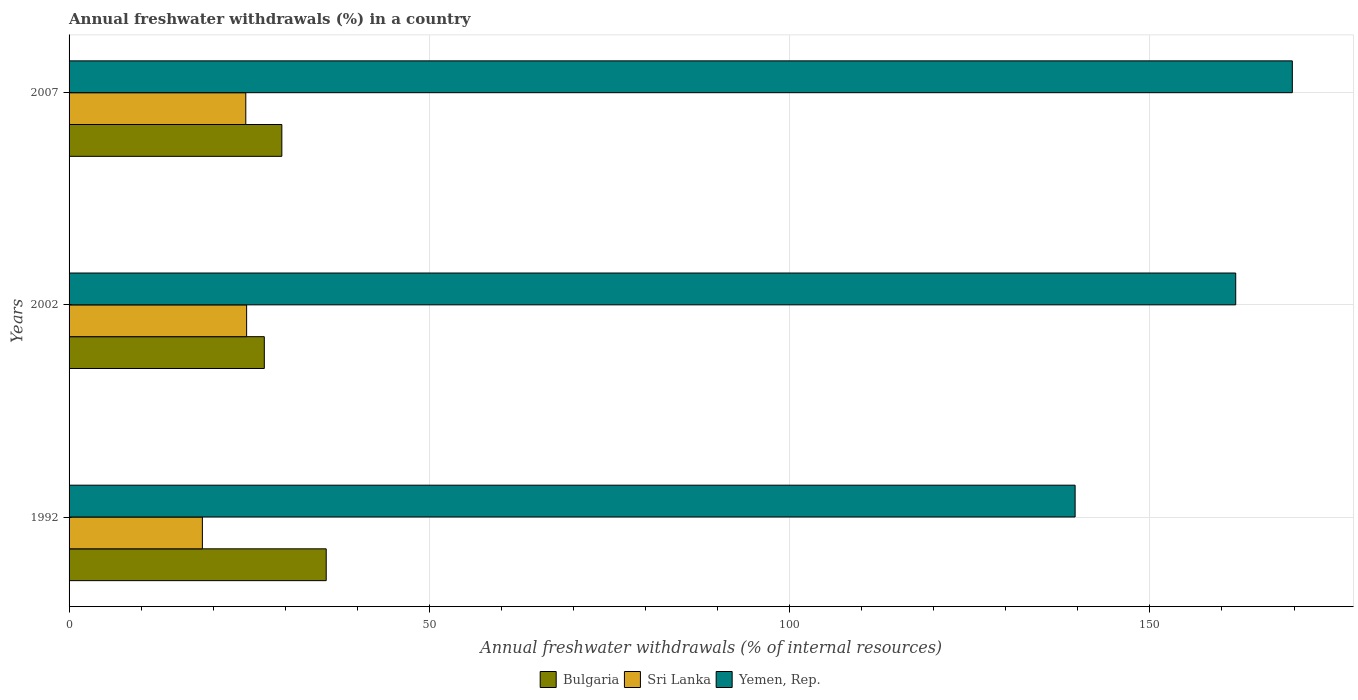How many different coloured bars are there?
Your answer should be compact. 3. How many groups of bars are there?
Offer a terse response. 3. Are the number of bars on each tick of the Y-axis equal?
Provide a succinct answer. Yes. How many bars are there on the 1st tick from the bottom?
Provide a succinct answer. 3. What is the label of the 2nd group of bars from the top?
Provide a succinct answer. 2002. In how many cases, is the number of bars for a given year not equal to the number of legend labels?
Make the answer very short. 0. What is the percentage of annual freshwater withdrawals in Yemen, Rep. in 2002?
Keep it short and to the point. 161.9. Across all years, what is the maximum percentage of annual freshwater withdrawals in Sri Lanka?
Give a very brief answer. 24.64. Across all years, what is the minimum percentage of annual freshwater withdrawals in Yemen, Rep.?
Provide a short and direct response. 139.62. What is the total percentage of annual freshwater withdrawals in Yemen, Rep. in the graph?
Make the answer very short. 471.29. What is the difference between the percentage of annual freshwater withdrawals in Bulgaria in 1992 and that in 2002?
Offer a very short reply. 8.59. What is the difference between the percentage of annual freshwater withdrawals in Bulgaria in 1992 and the percentage of annual freshwater withdrawals in Yemen, Rep. in 2002?
Offer a very short reply. -126.22. What is the average percentage of annual freshwater withdrawals in Sri Lanka per year?
Ensure brevity in your answer.  22.56. In the year 2002, what is the difference between the percentage of annual freshwater withdrawals in Bulgaria and percentage of annual freshwater withdrawals in Sri Lanka?
Ensure brevity in your answer.  2.46. What is the ratio of the percentage of annual freshwater withdrawals in Sri Lanka in 2002 to that in 2007?
Keep it short and to the point. 1. Is the difference between the percentage of annual freshwater withdrawals in Bulgaria in 2002 and 2007 greater than the difference between the percentage of annual freshwater withdrawals in Sri Lanka in 2002 and 2007?
Provide a succinct answer. No. What is the difference between the highest and the second highest percentage of annual freshwater withdrawals in Bulgaria?
Provide a short and direct response. 6.16. What is the difference between the highest and the lowest percentage of annual freshwater withdrawals in Bulgaria?
Provide a short and direct response. 8.59. In how many years, is the percentage of annual freshwater withdrawals in Bulgaria greater than the average percentage of annual freshwater withdrawals in Bulgaria taken over all years?
Give a very brief answer. 1. What does the 1st bar from the top in 2002 represents?
Your response must be concise. Yemen, Rep. What does the 2nd bar from the bottom in 1992 represents?
Your answer should be very brief. Sri Lanka. Is it the case that in every year, the sum of the percentage of annual freshwater withdrawals in Sri Lanka and percentage of annual freshwater withdrawals in Bulgaria is greater than the percentage of annual freshwater withdrawals in Yemen, Rep.?
Your answer should be compact. No. Are all the bars in the graph horizontal?
Your answer should be compact. Yes. How many years are there in the graph?
Your response must be concise. 3. What is the difference between two consecutive major ticks on the X-axis?
Provide a succinct answer. 50. Are the values on the major ticks of X-axis written in scientific E-notation?
Offer a very short reply. No. Does the graph contain any zero values?
Offer a terse response. No. How are the legend labels stacked?
Provide a short and direct response. Horizontal. What is the title of the graph?
Give a very brief answer. Annual freshwater withdrawals (%) in a country. What is the label or title of the X-axis?
Offer a terse response. Annual freshwater withdrawals (% of internal resources). What is the Annual freshwater withdrawals (% of internal resources) of Bulgaria in 1992?
Provide a succinct answer. 35.69. What is the Annual freshwater withdrawals (% of internal resources) in Sri Lanka in 1992?
Ensure brevity in your answer.  18.5. What is the Annual freshwater withdrawals (% of internal resources) of Yemen, Rep. in 1992?
Keep it short and to the point. 139.62. What is the Annual freshwater withdrawals (% of internal resources) of Bulgaria in 2002?
Keep it short and to the point. 27.1. What is the Annual freshwater withdrawals (% of internal resources) of Sri Lanka in 2002?
Make the answer very short. 24.64. What is the Annual freshwater withdrawals (% of internal resources) in Yemen, Rep. in 2002?
Keep it short and to the point. 161.9. What is the Annual freshwater withdrawals (% of internal resources) in Bulgaria in 2007?
Ensure brevity in your answer.  29.53. What is the Annual freshwater withdrawals (% of internal resources) of Sri Lanka in 2007?
Your response must be concise. 24.53. What is the Annual freshwater withdrawals (% of internal resources) of Yemen, Rep. in 2007?
Your answer should be very brief. 169.76. Across all years, what is the maximum Annual freshwater withdrawals (% of internal resources) of Bulgaria?
Give a very brief answer. 35.69. Across all years, what is the maximum Annual freshwater withdrawals (% of internal resources) of Sri Lanka?
Ensure brevity in your answer.  24.64. Across all years, what is the maximum Annual freshwater withdrawals (% of internal resources) in Yemen, Rep.?
Provide a succinct answer. 169.76. Across all years, what is the minimum Annual freshwater withdrawals (% of internal resources) of Bulgaria?
Your answer should be compact. 27.1. Across all years, what is the minimum Annual freshwater withdrawals (% of internal resources) of Sri Lanka?
Offer a terse response. 18.5. Across all years, what is the minimum Annual freshwater withdrawals (% of internal resources) of Yemen, Rep.?
Ensure brevity in your answer.  139.62. What is the total Annual freshwater withdrawals (% of internal resources) of Bulgaria in the graph?
Your answer should be compact. 92.31. What is the total Annual freshwater withdrawals (% of internal resources) in Sri Lanka in the graph?
Your answer should be compact. 67.67. What is the total Annual freshwater withdrawals (% of internal resources) in Yemen, Rep. in the graph?
Your response must be concise. 471.29. What is the difference between the Annual freshwater withdrawals (% of internal resources) of Bulgaria in 1992 and that in 2002?
Give a very brief answer. 8.59. What is the difference between the Annual freshwater withdrawals (% of internal resources) of Sri Lanka in 1992 and that in 2002?
Offer a terse response. -6.14. What is the difference between the Annual freshwater withdrawals (% of internal resources) in Yemen, Rep. in 1992 and that in 2002?
Provide a short and direct response. -22.29. What is the difference between the Annual freshwater withdrawals (% of internal resources) of Bulgaria in 1992 and that in 2007?
Make the answer very short. 6.16. What is the difference between the Annual freshwater withdrawals (% of internal resources) in Sri Lanka in 1992 and that in 2007?
Offer a terse response. -6.02. What is the difference between the Annual freshwater withdrawals (% of internal resources) of Yemen, Rep. in 1992 and that in 2007?
Provide a short and direct response. -30.14. What is the difference between the Annual freshwater withdrawals (% of internal resources) in Bulgaria in 2002 and that in 2007?
Your answer should be very brief. -2.43. What is the difference between the Annual freshwater withdrawals (% of internal resources) in Sri Lanka in 2002 and that in 2007?
Keep it short and to the point. 0.11. What is the difference between the Annual freshwater withdrawals (% of internal resources) of Yemen, Rep. in 2002 and that in 2007?
Provide a succinct answer. -7.86. What is the difference between the Annual freshwater withdrawals (% of internal resources) in Bulgaria in 1992 and the Annual freshwater withdrawals (% of internal resources) in Sri Lanka in 2002?
Provide a succinct answer. 11.05. What is the difference between the Annual freshwater withdrawals (% of internal resources) in Bulgaria in 1992 and the Annual freshwater withdrawals (% of internal resources) in Yemen, Rep. in 2002?
Offer a terse response. -126.22. What is the difference between the Annual freshwater withdrawals (% of internal resources) of Sri Lanka in 1992 and the Annual freshwater withdrawals (% of internal resources) of Yemen, Rep. in 2002?
Keep it short and to the point. -143.4. What is the difference between the Annual freshwater withdrawals (% of internal resources) in Bulgaria in 1992 and the Annual freshwater withdrawals (% of internal resources) in Sri Lanka in 2007?
Give a very brief answer. 11.16. What is the difference between the Annual freshwater withdrawals (% of internal resources) of Bulgaria in 1992 and the Annual freshwater withdrawals (% of internal resources) of Yemen, Rep. in 2007?
Offer a terse response. -134.08. What is the difference between the Annual freshwater withdrawals (% of internal resources) in Sri Lanka in 1992 and the Annual freshwater withdrawals (% of internal resources) in Yemen, Rep. in 2007?
Provide a short and direct response. -151.26. What is the difference between the Annual freshwater withdrawals (% of internal resources) in Bulgaria in 2002 and the Annual freshwater withdrawals (% of internal resources) in Sri Lanka in 2007?
Offer a very short reply. 2.57. What is the difference between the Annual freshwater withdrawals (% of internal resources) of Bulgaria in 2002 and the Annual freshwater withdrawals (% of internal resources) of Yemen, Rep. in 2007?
Ensure brevity in your answer.  -142.67. What is the difference between the Annual freshwater withdrawals (% of internal resources) of Sri Lanka in 2002 and the Annual freshwater withdrawals (% of internal resources) of Yemen, Rep. in 2007?
Offer a very short reply. -145.12. What is the average Annual freshwater withdrawals (% of internal resources) of Bulgaria per year?
Keep it short and to the point. 30.77. What is the average Annual freshwater withdrawals (% of internal resources) of Sri Lanka per year?
Ensure brevity in your answer.  22.56. What is the average Annual freshwater withdrawals (% of internal resources) of Yemen, Rep. per year?
Your answer should be compact. 157.1. In the year 1992, what is the difference between the Annual freshwater withdrawals (% of internal resources) of Bulgaria and Annual freshwater withdrawals (% of internal resources) of Sri Lanka?
Offer a terse response. 17.18. In the year 1992, what is the difference between the Annual freshwater withdrawals (% of internal resources) in Bulgaria and Annual freshwater withdrawals (% of internal resources) in Yemen, Rep.?
Ensure brevity in your answer.  -103.93. In the year 1992, what is the difference between the Annual freshwater withdrawals (% of internal resources) in Sri Lanka and Annual freshwater withdrawals (% of internal resources) in Yemen, Rep.?
Ensure brevity in your answer.  -121.12. In the year 2002, what is the difference between the Annual freshwater withdrawals (% of internal resources) in Bulgaria and Annual freshwater withdrawals (% of internal resources) in Sri Lanka?
Provide a short and direct response. 2.46. In the year 2002, what is the difference between the Annual freshwater withdrawals (% of internal resources) of Bulgaria and Annual freshwater withdrawals (% of internal resources) of Yemen, Rep.?
Offer a terse response. -134.81. In the year 2002, what is the difference between the Annual freshwater withdrawals (% of internal resources) of Sri Lanka and Annual freshwater withdrawals (% of internal resources) of Yemen, Rep.?
Make the answer very short. -137.26. In the year 2007, what is the difference between the Annual freshwater withdrawals (% of internal resources) of Bulgaria and Annual freshwater withdrawals (% of internal resources) of Sri Lanka?
Your answer should be compact. 5. In the year 2007, what is the difference between the Annual freshwater withdrawals (% of internal resources) of Bulgaria and Annual freshwater withdrawals (% of internal resources) of Yemen, Rep.?
Ensure brevity in your answer.  -140.23. In the year 2007, what is the difference between the Annual freshwater withdrawals (% of internal resources) in Sri Lanka and Annual freshwater withdrawals (% of internal resources) in Yemen, Rep.?
Keep it short and to the point. -145.24. What is the ratio of the Annual freshwater withdrawals (% of internal resources) of Bulgaria in 1992 to that in 2002?
Your answer should be compact. 1.32. What is the ratio of the Annual freshwater withdrawals (% of internal resources) in Sri Lanka in 1992 to that in 2002?
Keep it short and to the point. 0.75. What is the ratio of the Annual freshwater withdrawals (% of internal resources) of Yemen, Rep. in 1992 to that in 2002?
Provide a succinct answer. 0.86. What is the ratio of the Annual freshwater withdrawals (% of internal resources) of Bulgaria in 1992 to that in 2007?
Give a very brief answer. 1.21. What is the ratio of the Annual freshwater withdrawals (% of internal resources) in Sri Lanka in 1992 to that in 2007?
Provide a short and direct response. 0.75. What is the ratio of the Annual freshwater withdrawals (% of internal resources) in Yemen, Rep. in 1992 to that in 2007?
Provide a short and direct response. 0.82. What is the ratio of the Annual freshwater withdrawals (% of internal resources) in Bulgaria in 2002 to that in 2007?
Your response must be concise. 0.92. What is the ratio of the Annual freshwater withdrawals (% of internal resources) of Sri Lanka in 2002 to that in 2007?
Provide a succinct answer. 1. What is the ratio of the Annual freshwater withdrawals (% of internal resources) of Yemen, Rep. in 2002 to that in 2007?
Your response must be concise. 0.95. What is the difference between the highest and the second highest Annual freshwater withdrawals (% of internal resources) of Bulgaria?
Offer a very short reply. 6.16. What is the difference between the highest and the second highest Annual freshwater withdrawals (% of internal resources) of Sri Lanka?
Your answer should be very brief. 0.11. What is the difference between the highest and the second highest Annual freshwater withdrawals (% of internal resources) in Yemen, Rep.?
Offer a terse response. 7.86. What is the difference between the highest and the lowest Annual freshwater withdrawals (% of internal resources) of Bulgaria?
Your answer should be compact. 8.59. What is the difference between the highest and the lowest Annual freshwater withdrawals (% of internal resources) of Sri Lanka?
Ensure brevity in your answer.  6.14. What is the difference between the highest and the lowest Annual freshwater withdrawals (% of internal resources) in Yemen, Rep.?
Your response must be concise. 30.14. 